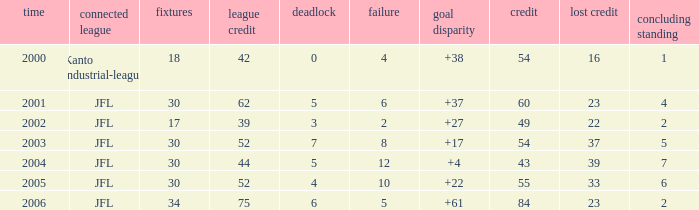I want the total number of matches for draw less than 7 and lost point of 16 with lose more than 4 0.0. 